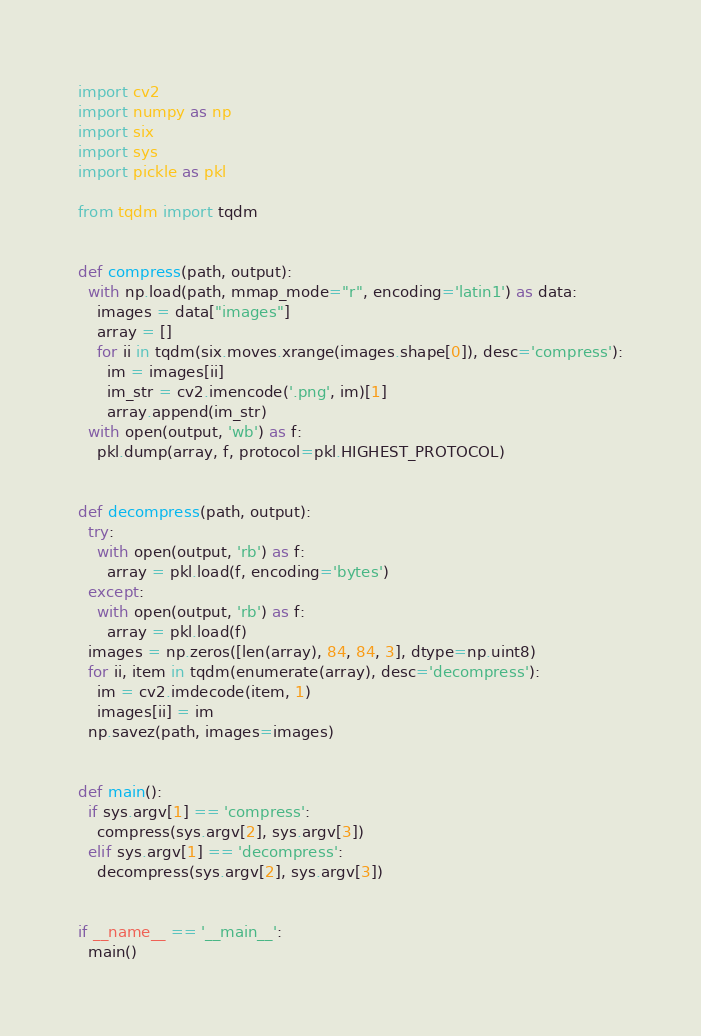Convert code to text. <code><loc_0><loc_0><loc_500><loc_500><_Python_>import cv2
import numpy as np
import six
import sys
import pickle as pkl

from tqdm import tqdm


def compress(path, output):
  with np.load(path, mmap_mode="r", encoding='latin1') as data:
    images = data["images"]
    array = []
    for ii in tqdm(six.moves.xrange(images.shape[0]), desc='compress'):
      im = images[ii]
      im_str = cv2.imencode('.png', im)[1]
      array.append(im_str)
  with open(output, 'wb') as f:
    pkl.dump(array, f, protocol=pkl.HIGHEST_PROTOCOL)


def decompress(path, output):
  try:
    with open(output, 'rb') as f:
      array = pkl.load(f, encoding='bytes')
  except:
    with open(output, 'rb') as f:
      array = pkl.load(f)
  images = np.zeros([len(array), 84, 84, 3], dtype=np.uint8)
  for ii, item in tqdm(enumerate(array), desc='decompress'):
    im = cv2.imdecode(item, 1)
    images[ii] = im
  np.savez(path, images=images)


def main():
  if sys.argv[1] == 'compress':
    compress(sys.argv[2], sys.argv[3])
  elif sys.argv[1] == 'decompress':
    decompress(sys.argv[2], sys.argv[3])


if __name__ == '__main__':
  main()
</code> 